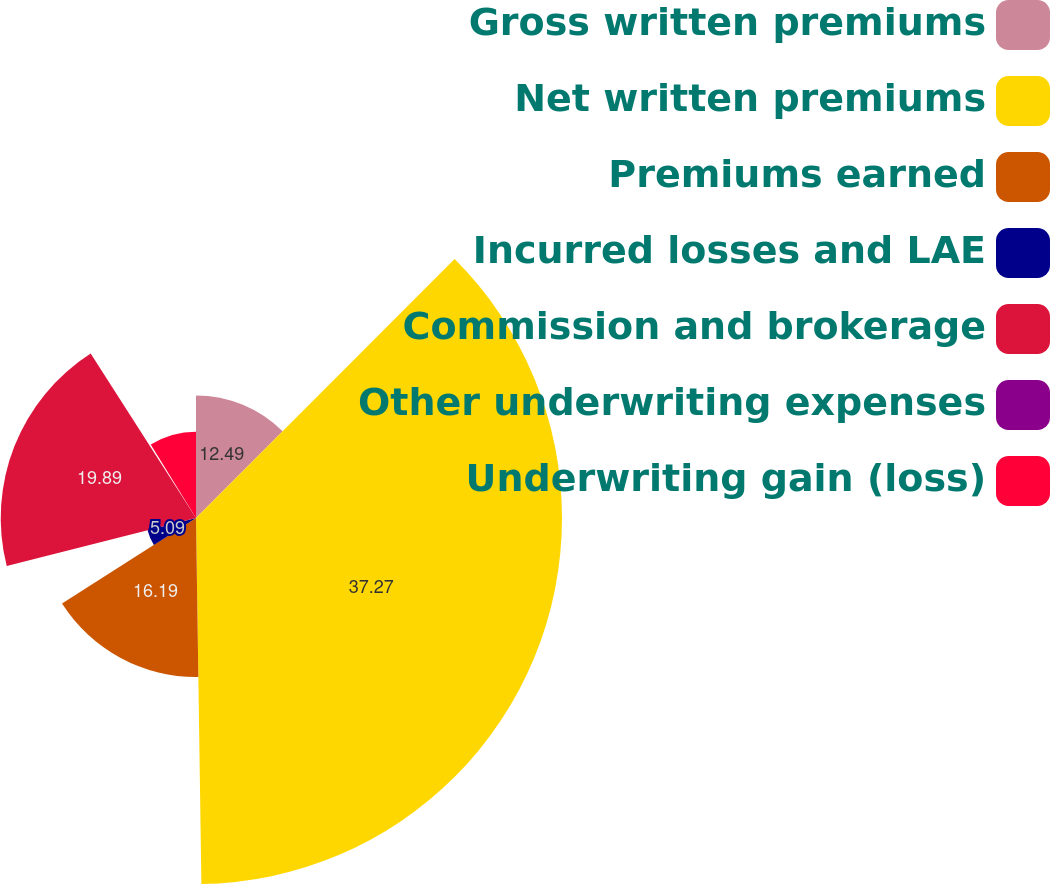Convert chart. <chart><loc_0><loc_0><loc_500><loc_500><pie_chart><fcel>Gross written premiums<fcel>Net written premiums<fcel>Premiums earned<fcel>Incurred losses and LAE<fcel>Commission and brokerage<fcel>Other underwriting expenses<fcel>Underwriting gain (loss)<nl><fcel>12.49%<fcel>37.28%<fcel>16.19%<fcel>5.09%<fcel>19.89%<fcel>0.28%<fcel>8.79%<nl></chart> 